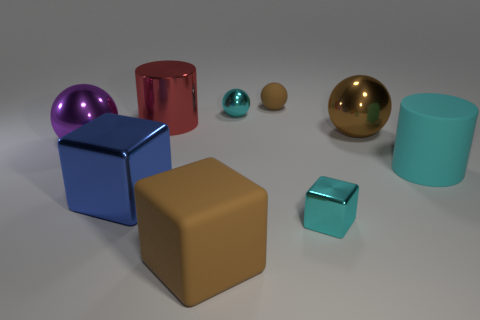Are there any cyan matte cylinders of the same size as the brown matte block?
Make the answer very short. Yes. What is the color of the big rubber thing on the left side of the large cyan cylinder?
Offer a terse response. Brown. What shape is the matte thing that is both in front of the small cyan sphere and right of the brown rubber cube?
Provide a succinct answer. Cylinder. What number of other things have the same shape as the purple thing?
Your answer should be compact. 3. What number of small brown shiny cylinders are there?
Provide a short and direct response. 0. What is the size of the cube that is to the left of the tiny brown rubber ball and to the right of the blue shiny cube?
Your response must be concise. Large. There is a blue object that is the same size as the shiny cylinder; what is its shape?
Offer a very short reply. Cube. There is a large brown thing to the left of the tiny cyan cube; is there a metallic block that is in front of it?
Offer a very short reply. No. The other tiny metal object that is the same shape as the purple object is what color?
Keep it short and to the point. Cyan. Does the metal ball that is right of the small cyan metal sphere have the same color as the rubber sphere?
Keep it short and to the point. Yes. 